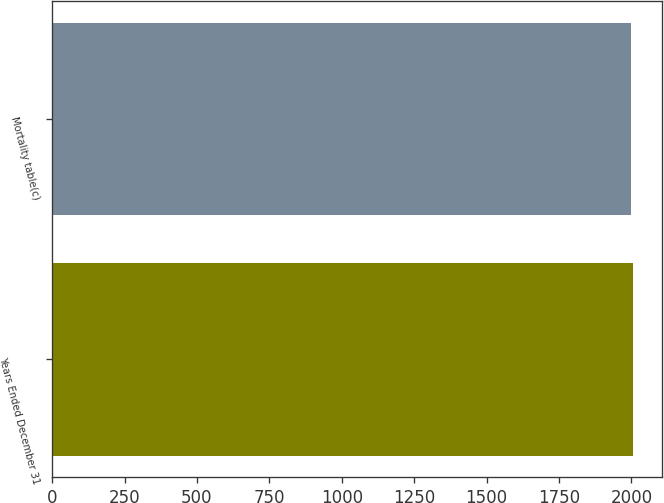Convert chart to OTSL. <chart><loc_0><loc_0><loc_500><loc_500><bar_chart><fcel>Years Ended December 31<fcel>Mortality table(c)<nl><fcel>2006<fcel>2000<nl></chart> 